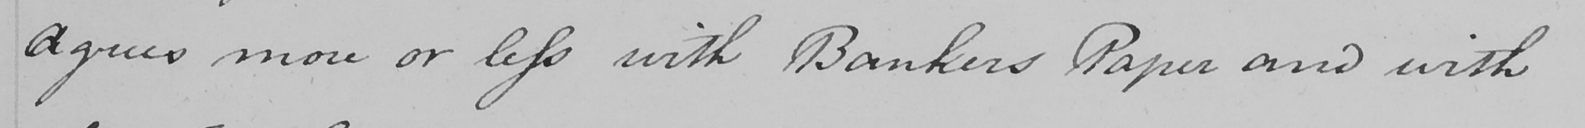What text is written in this handwritten line? Agrees more or less with Bankers Paper and with 